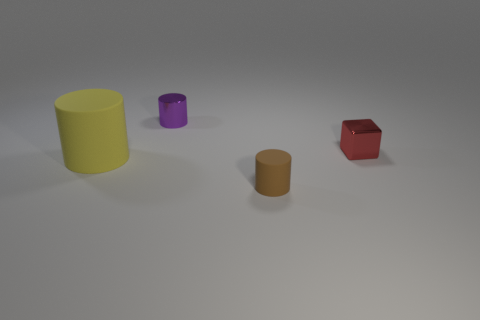Add 2 big rubber cylinders. How many objects exist? 6 Subtract all shiny cylinders. How many cylinders are left? 2 Subtract all yellow cylinders. How many cylinders are left? 2 Subtract all cylinders. How many objects are left? 1 Subtract all yellow rubber cylinders. Subtract all big purple blocks. How many objects are left? 3 Add 3 tiny cylinders. How many tiny cylinders are left? 5 Add 4 brown balls. How many brown balls exist? 4 Subtract 0 purple spheres. How many objects are left? 4 Subtract all blue cylinders. Subtract all yellow cubes. How many cylinders are left? 3 Subtract all gray cylinders. How many yellow cubes are left? 0 